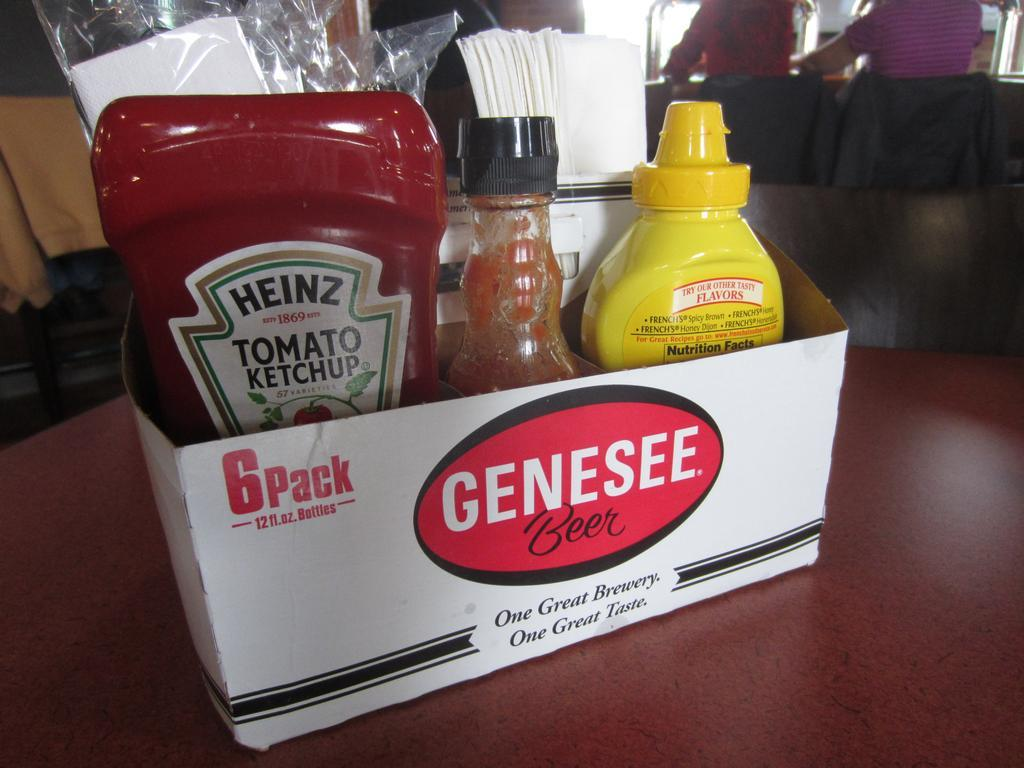What does the use of a beer caddy to hold condiments suggest about the restaurant's atmosphere? The use of a beer caddy as a condiment holder suggests a laid-back and innovative atmosphere at the restaurant. It reflects a casual, perhaps eclectic style where functionality and creativity merge. This choice might indicate a friendly space where upcycling is valued and the dining experience is infused with a sense of informal charm. Such an environment likely appeals to a diverse clientele who appreciate both the practicality and the aesthetic of repurposing everyday items in unique ways. 